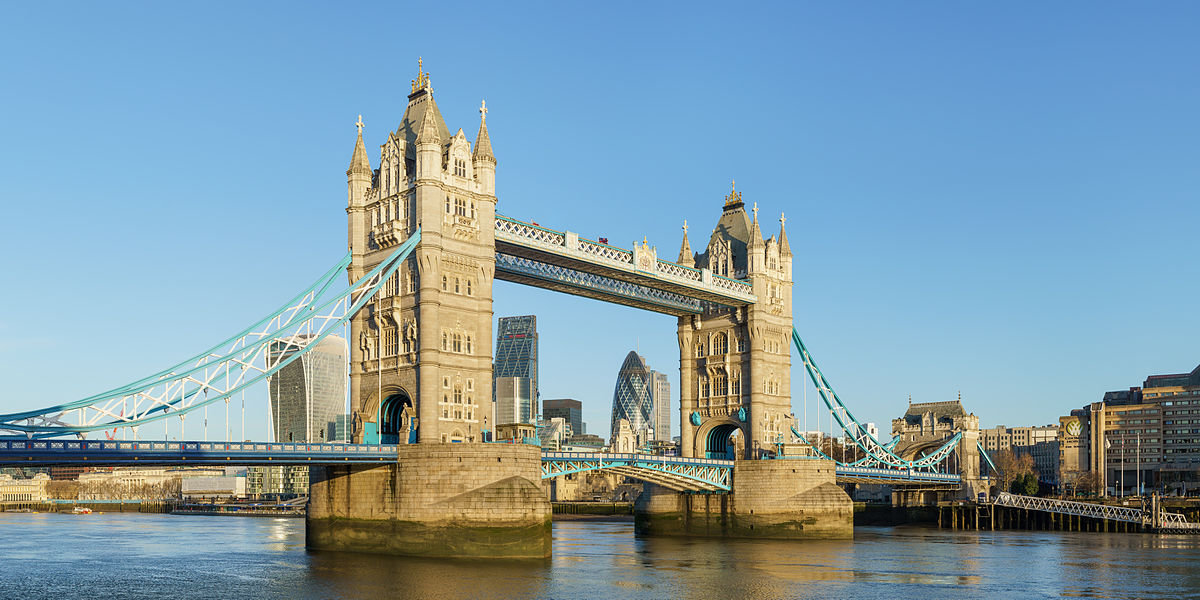What architectural style is Tower Bridge built in? The architectural style of Tower Bridge is a blend of Gothic Revival and Victorian elements. The bridge's facade is adorned with ornate stonework and striking blue and white paint, which accentuates its iconic status. The two towers display a high level of Gothic detailing, complete with turrets and intricate masonry, making it a distinctive feature of London's skyline. 